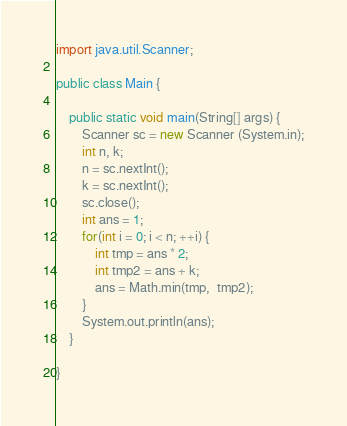Convert code to text. <code><loc_0><loc_0><loc_500><loc_500><_Java_>import java.util.Scanner;

public class Main {

	public static void main(String[] args) {
		Scanner sc = new Scanner (System.in);
		int n, k;
		n = sc.nextInt();
		k = sc.nextInt();
		sc.close();
		int ans = 1;
		for(int i = 0; i < n; ++i) {
			int tmp = ans * 2;
			int tmp2 = ans + k;
			ans = Math.min(tmp,  tmp2);
		}
		System.out.println(ans);
	}

}
</code> 